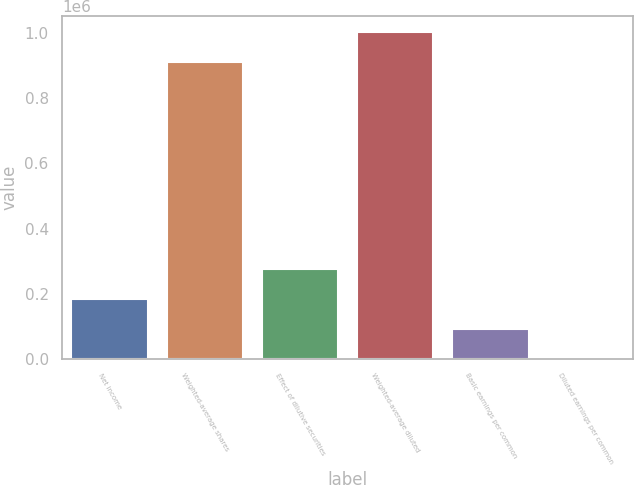Convert chart. <chart><loc_0><loc_0><loc_500><loc_500><bar_chart><fcel>Net income<fcel>Weighted-average shares<fcel>Effect of dilutive securities<fcel>Weighted-average diluted<fcel>Basic earnings per common<fcel>Diluted earnings per common<nl><fcel>184955<fcel>909461<fcel>277424<fcel>1.00193e+06<fcel>92484.8<fcel>15.15<nl></chart> 